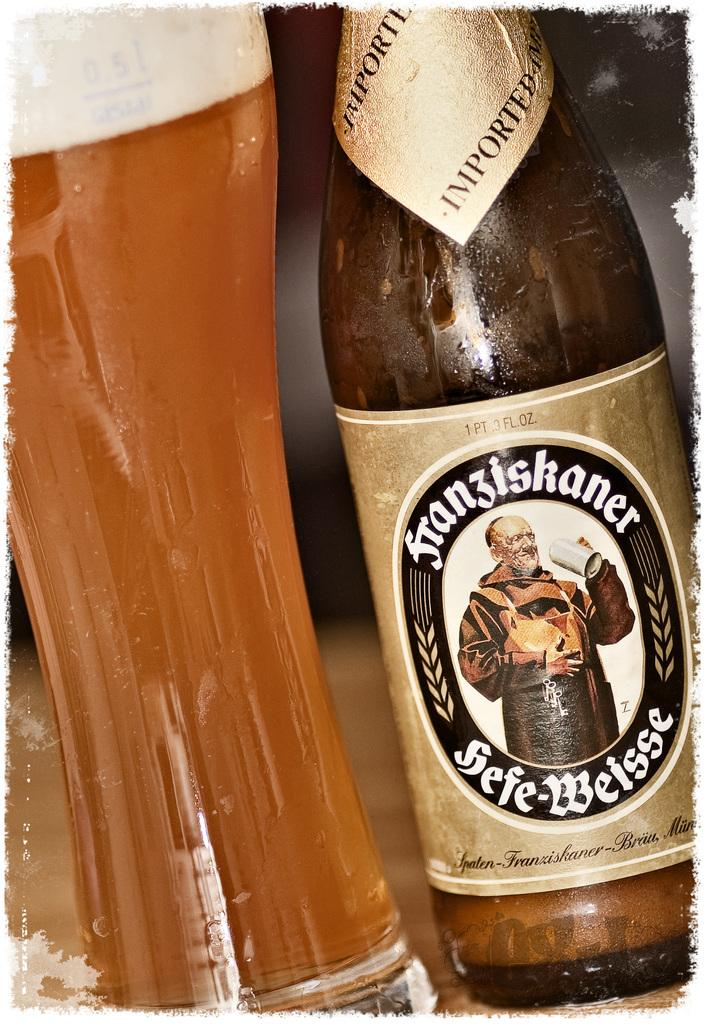<image>
Write a terse but informative summary of the picture. A bottle of beer says on the neck label that it was imported. 